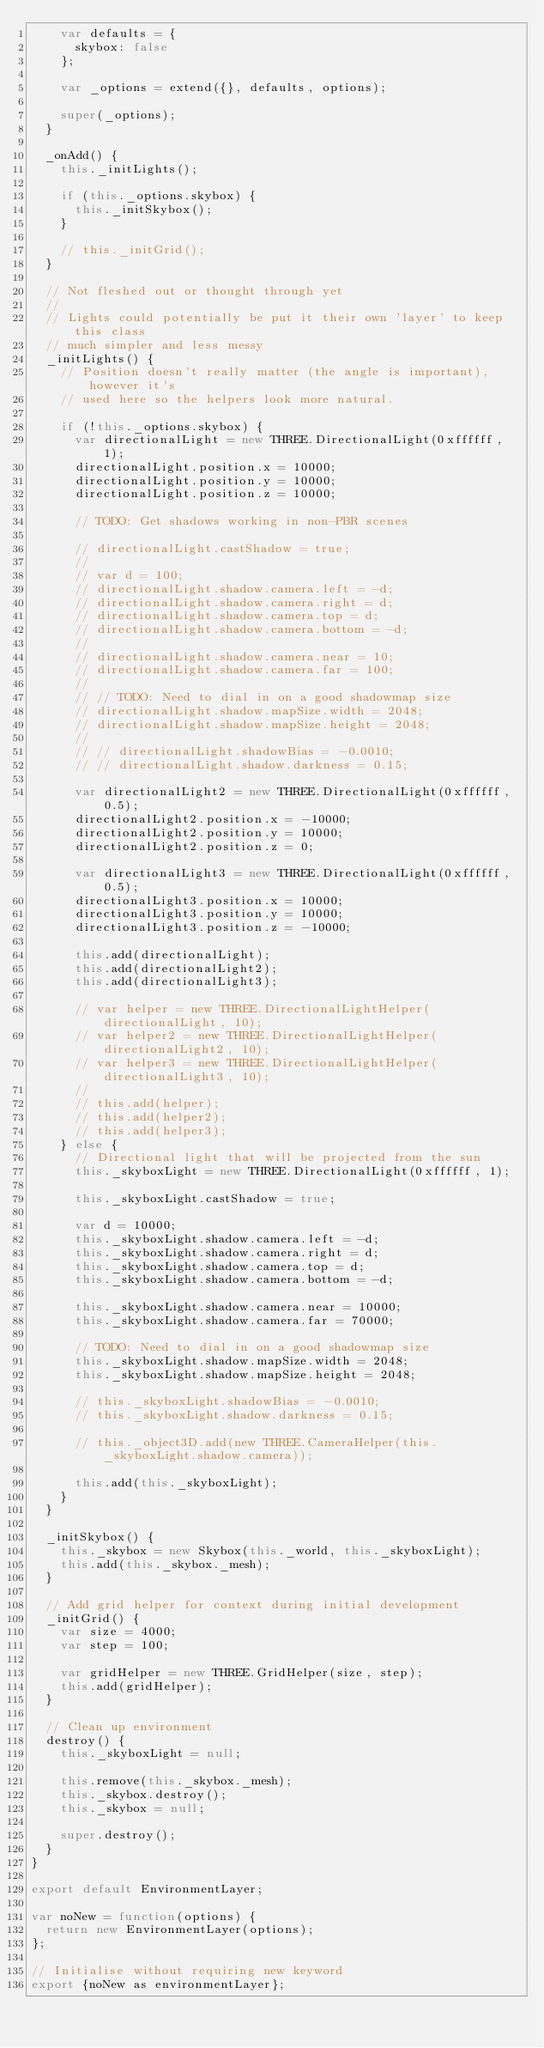<code> <loc_0><loc_0><loc_500><loc_500><_JavaScript_>    var defaults = {
      skybox: false
    };

    var _options = extend({}, defaults, options);

    super(_options);
  }

  _onAdd() {
    this._initLights();

    if (this._options.skybox) {
      this._initSkybox();
    }

    // this._initGrid();
  }

  // Not fleshed out or thought through yet
  //
  // Lights could potentially be put it their own 'layer' to keep this class
  // much simpler and less messy
  _initLights() {
    // Position doesn't really matter (the angle is important), however it's
    // used here so the helpers look more natural.

    if (!this._options.skybox) {
      var directionalLight = new THREE.DirectionalLight(0xffffff, 1);
      directionalLight.position.x = 10000;
      directionalLight.position.y = 10000;
      directionalLight.position.z = 10000;

      // TODO: Get shadows working in non-PBR scenes

      // directionalLight.castShadow = true;
      //
      // var d = 100;
      // directionalLight.shadow.camera.left = -d;
      // directionalLight.shadow.camera.right = d;
      // directionalLight.shadow.camera.top = d;
      // directionalLight.shadow.camera.bottom = -d;
      //
      // directionalLight.shadow.camera.near = 10;
      // directionalLight.shadow.camera.far = 100;
      //
      // // TODO: Need to dial in on a good shadowmap size
      // directionalLight.shadow.mapSize.width = 2048;
      // directionalLight.shadow.mapSize.height = 2048;
      //
      // // directionalLight.shadowBias = -0.0010;
      // // directionalLight.shadow.darkness = 0.15;

      var directionalLight2 = new THREE.DirectionalLight(0xffffff, 0.5);
      directionalLight2.position.x = -10000;
      directionalLight2.position.y = 10000;
      directionalLight2.position.z = 0;

      var directionalLight3 = new THREE.DirectionalLight(0xffffff, 0.5);
      directionalLight3.position.x = 10000;
      directionalLight3.position.y = 10000;
      directionalLight3.position.z = -10000;

      this.add(directionalLight);
      this.add(directionalLight2);
      this.add(directionalLight3);

      // var helper = new THREE.DirectionalLightHelper(directionalLight, 10);
      // var helper2 = new THREE.DirectionalLightHelper(directionalLight2, 10);
      // var helper3 = new THREE.DirectionalLightHelper(directionalLight3, 10);
      //
      // this.add(helper);
      // this.add(helper2);
      // this.add(helper3);
    } else {
      // Directional light that will be projected from the sun
      this._skyboxLight = new THREE.DirectionalLight(0xffffff, 1);

      this._skyboxLight.castShadow = true;

      var d = 10000;
      this._skyboxLight.shadow.camera.left = -d;
      this._skyboxLight.shadow.camera.right = d;
      this._skyboxLight.shadow.camera.top = d;
      this._skyboxLight.shadow.camera.bottom = -d;

      this._skyboxLight.shadow.camera.near = 10000;
      this._skyboxLight.shadow.camera.far = 70000;

      // TODO: Need to dial in on a good shadowmap size
      this._skyboxLight.shadow.mapSize.width = 2048;
      this._skyboxLight.shadow.mapSize.height = 2048;

      // this._skyboxLight.shadowBias = -0.0010;
      // this._skyboxLight.shadow.darkness = 0.15;

      // this._object3D.add(new THREE.CameraHelper(this._skyboxLight.shadow.camera));

      this.add(this._skyboxLight);
    }
  }

  _initSkybox() {
    this._skybox = new Skybox(this._world, this._skyboxLight);
    this.add(this._skybox._mesh);
  }

  // Add grid helper for context during initial development
  _initGrid() {
    var size = 4000;
    var step = 100;

    var gridHelper = new THREE.GridHelper(size, step);
    this.add(gridHelper);
  }

  // Clean up environment
  destroy() {
    this._skyboxLight = null;

    this.remove(this._skybox._mesh);
    this._skybox.destroy();
    this._skybox = null;

    super.destroy();
  }
}

export default EnvironmentLayer;

var noNew = function(options) {
  return new EnvironmentLayer(options);
};

// Initialise without requiring new keyword
export {noNew as environmentLayer};
</code> 